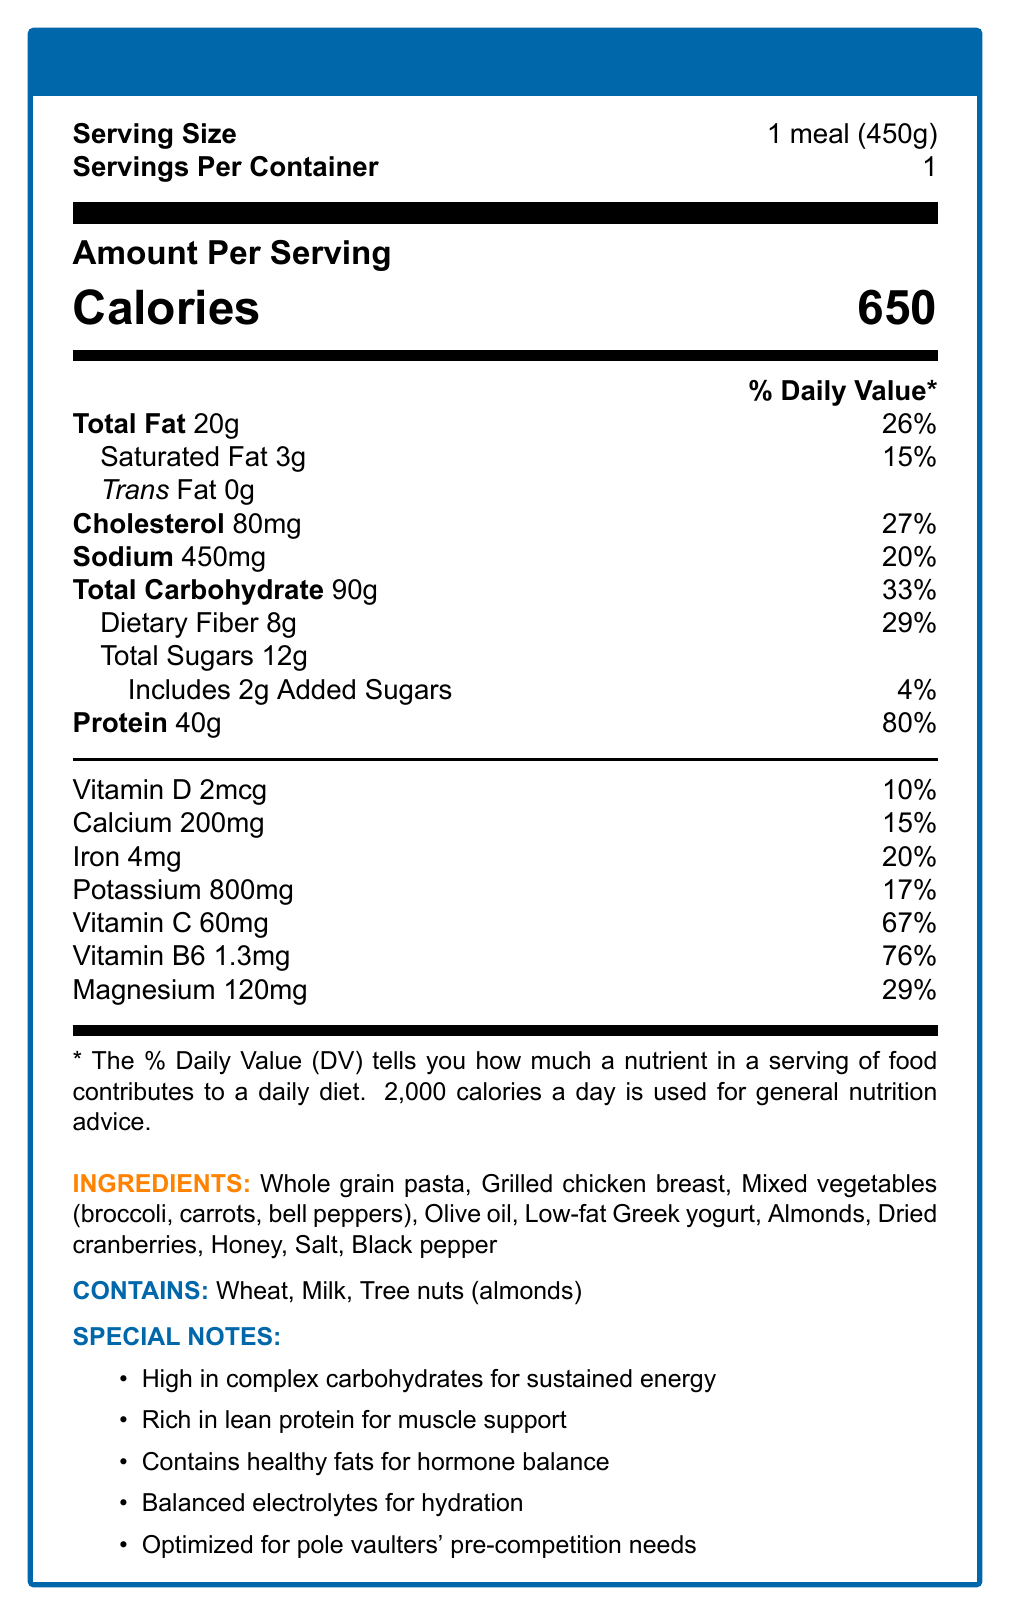what is the serving size? The document states that the serving size is 1 meal (450g).
Answer: 1 meal (450g) how many calories are in one serving? The nutrition facts indicate that a serving contains 650 calories.
Answer: 650 what is the total fat content in one serving? The document specifies that the total fat in one serving is 20 grams.
Answer: 20g how much cholesterol does this meal contain? The document lists 80mg as the cholesterol content per serving.
Answer: 80mg what percentage of the daily value of protein does one serving provide? According to the nutrition facts, one serving provides 80% of the daily value for protein.
Answer: 80% which ingredient is used as a source of lean protein? A. Whole grain pasta B. Grilled chicken breast C. Almonds The special notes mention that the meal is rich in lean protein, which can be attributed to the grilled chicken breast.
Answer: B which of the following is an allergen listed in the document? A. Chocolate B. Shellfish C. Milk The allergens listed are wheat, milk, and tree nuts (almonds), which includes milk.
Answer: C does this meal contain trans fat? The document specifies that the amount of trans fat is 0 grams, indicating there is no trans fat in the meal.
Answer: No is this meal optimized for pole vaulters' pre-competition needs? The special notes mention that the meal is optimized for pole vaulters' pre-competition needs.
Answer: Yes describe the main nutritional benefits of this pre-competition meal for a pole vaulter. The special notes section of the document highlights these nutritional benefits tailored to support the needs of a pole vaulter.
Answer: The meal is high in complex carbohydrates for sustained energy, rich in lean protein for muscle support, contains healthy fats for hormone balance, and has balanced electrolytes for hydration. what is the ratio of dietary fiber to total carbohydrate in this meal? The document lists 8 grams of dietary fiber and 90 grams of total carbohydrates per serving.
Answer: 8g to 90g how many grams of added sugars does the meal include? The nutrition facts indicate that the meal includes 2 grams of added sugars.
Answer: 2g what is the percentage daily value of vitamin B6 provided in one serving? The document lists the daily value for vitamin B6 as 76%.
Answer: 76% how many grams of total sugars are there in one serving? The nutrition facts indicate there are 12 grams of total sugars per serving.
Answer: 12g what is the serving size in ounces? The document lists the serving size in grams (450g), but does not provide a conversion to ounces.
Answer: Cannot be determined 